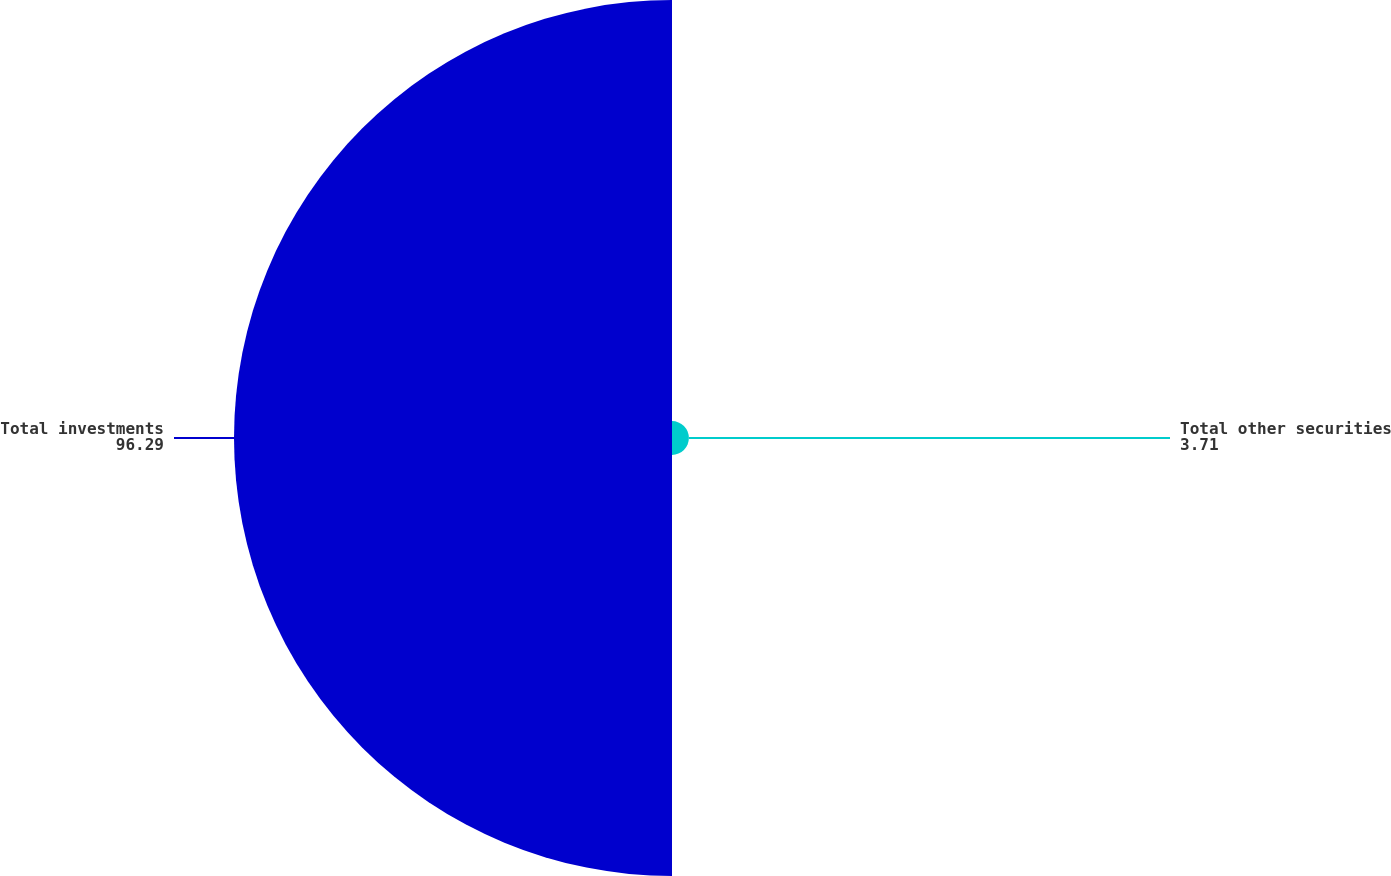<chart> <loc_0><loc_0><loc_500><loc_500><pie_chart><fcel>Total other securities<fcel>Total investments<nl><fcel>3.71%<fcel>96.29%<nl></chart> 